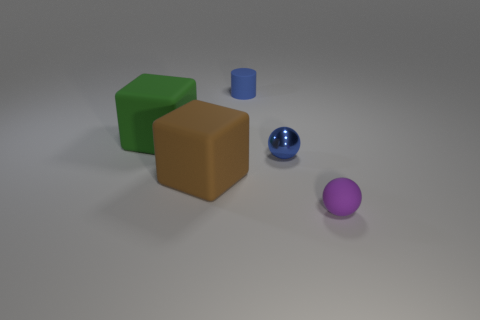Add 4 small blue metal spheres. How many objects exist? 9 Subtract all cubes. How many objects are left? 3 Add 2 small things. How many small things exist? 5 Subtract 0 yellow spheres. How many objects are left? 5 Subtract all brown rubber blocks. Subtract all tiny purple matte balls. How many objects are left? 3 Add 2 tiny blue shiny objects. How many tiny blue shiny objects are left? 3 